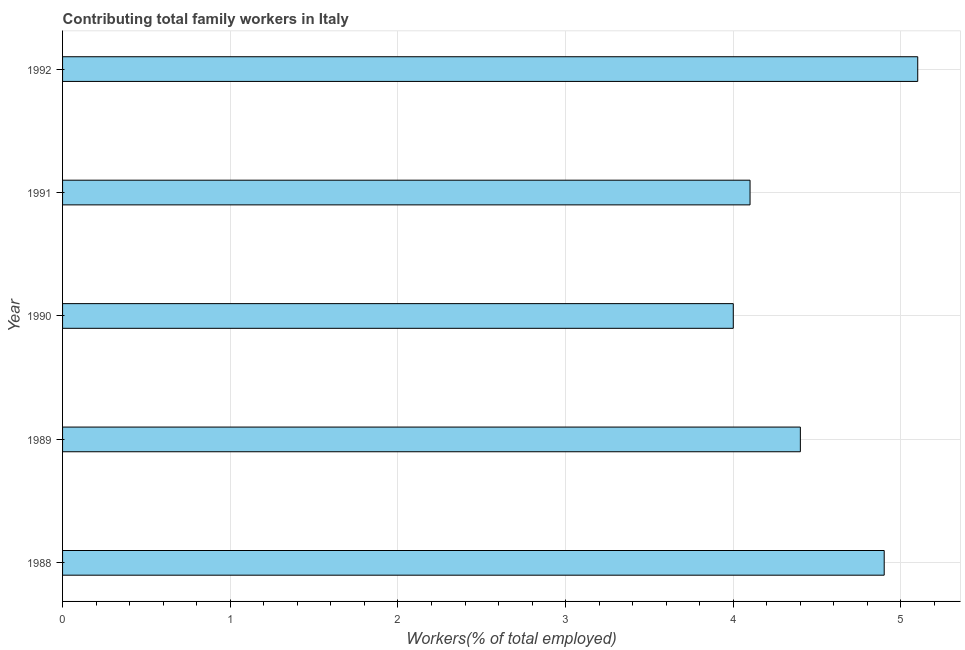What is the title of the graph?
Offer a terse response. Contributing total family workers in Italy. What is the label or title of the X-axis?
Offer a terse response. Workers(% of total employed). What is the contributing family workers in 1992?
Offer a very short reply. 5.1. Across all years, what is the maximum contributing family workers?
Offer a very short reply. 5.1. What is the average contributing family workers per year?
Provide a succinct answer. 4.5. What is the median contributing family workers?
Provide a succinct answer. 4.4. In how many years, is the contributing family workers greater than 4.2 %?
Give a very brief answer. 3. Do a majority of the years between 1991 and 1988 (inclusive) have contributing family workers greater than 3.8 %?
Your answer should be compact. Yes. What is the ratio of the contributing family workers in 1989 to that in 1990?
Provide a succinct answer. 1.1. Is the contributing family workers in 1989 less than that in 1992?
Make the answer very short. Yes. Is the difference between the contributing family workers in 1988 and 1991 greater than the difference between any two years?
Your answer should be compact. No. Is the sum of the contributing family workers in 1988 and 1990 greater than the maximum contributing family workers across all years?
Offer a terse response. Yes. Are all the bars in the graph horizontal?
Give a very brief answer. Yes. How many years are there in the graph?
Your answer should be compact. 5. What is the Workers(% of total employed) in 1988?
Ensure brevity in your answer.  4.9. What is the Workers(% of total employed) in 1989?
Give a very brief answer. 4.4. What is the Workers(% of total employed) in 1990?
Give a very brief answer. 4. What is the Workers(% of total employed) in 1991?
Offer a terse response. 4.1. What is the Workers(% of total employed) in 1992?
Keep it short and to the point. 5.1. What is the difference between the Workers(% of total employed) in 1988 and 1989?
Offer a very short reply. 0.5. What is the difference between the Workers(% of total employed) in 1988 and 1990?
Offer a terse response. 0.9. What is the difference between the Workers(% of total employed) in 1988 and 1991?
Make the answer very short. 0.8. What is the difference between the Workers(% of total employed) in 1988 and 1992?
Your answer should be compact. -0.2. What is the difference between the Workers(% of total employed) in 1989 and 1991?
Give a very brief answer. 0.3. What is the difference between the Workers(% of total employed) in 1989 and 1992?
Provide a succinct answer. -0.7. What is the difference between the Workers(% of total employed) in 1991 and 1992?
Make the answer very short. -1. What is the ratio of the Workers(% of total employed) in 1988 to that in 1989?
Keep it short and to the point. 1.11. What is the ratio of the Workers(% of total employed) in 1988 to that in 1990?
Offer a very short reply. 1.23. What is the ratio of the Workers(% of total employed) in 1988 to that in 1991?
Offer a very short reply. 1.2. What is the ratio of the Workers(% of total employed) in 1989 to that in 1991?
Ensure brevity in your answer.  1.07. What is the ratio of the Workers(% of total employed) in 1989 to that in 1992?
Provide a short and direct response. 0.86. What is the ratio of the Workers(% of total employed) in 1990 to that in 1991?
Provide a succinct answer. 0.98. What is the ratio of the Workers(% of total employed) in 1990 to that in 1992?
Make the answer very short. 0.78. What is the ratio of the Workers(% of total employed) in 1991 to that in 1992?
Your answer should be compact. 0.8. 